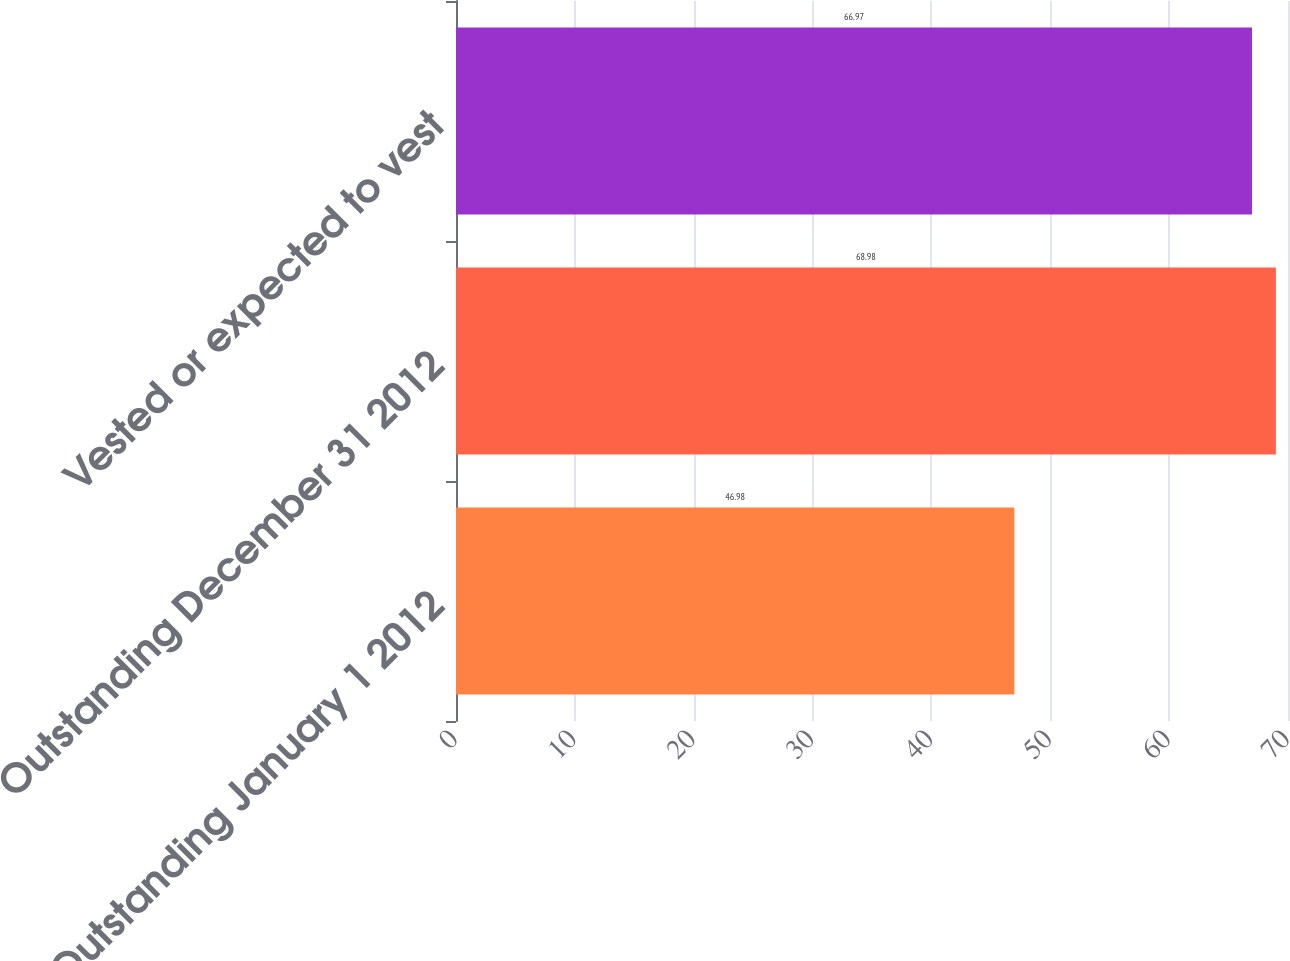<chart> <loc_0><loc_0><loc_500><loc_500><bar_chart><fcel>Outstanding January 1 2012<fcel>Outstanding December 31 2012<fcel>Vested or expected to vest<nl><fcel>46.98<fcel>68.98<fcel>66.97<nl></chart> 